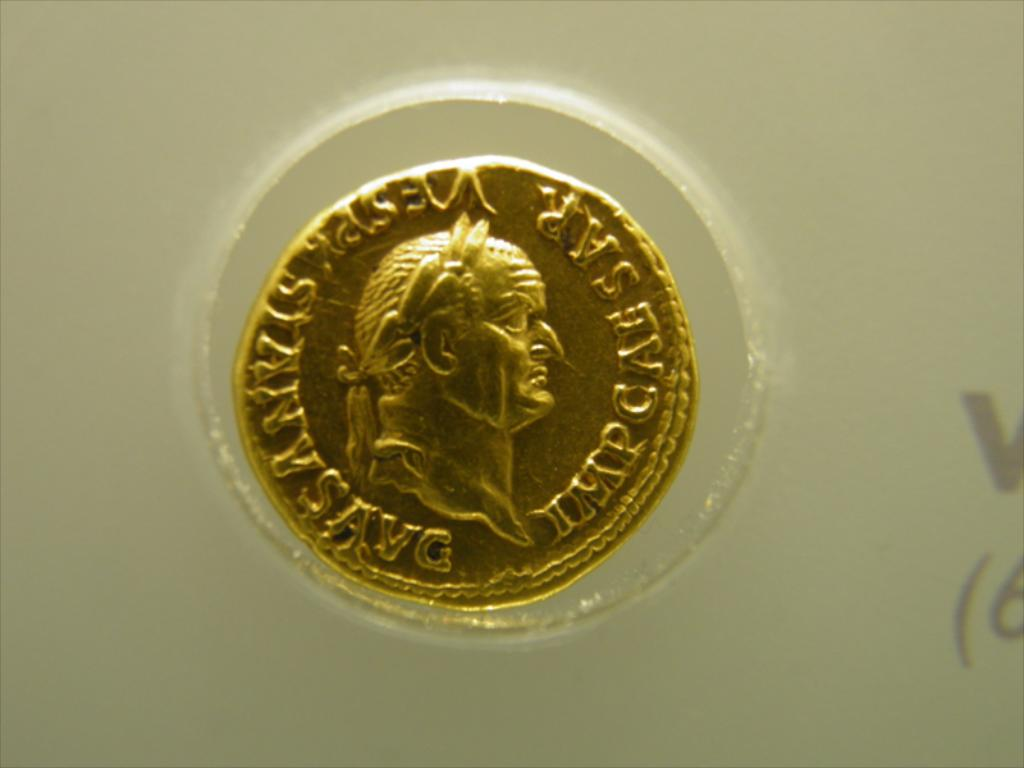What is the historical importance of coins like the one in the image? Coins like the one shown often play significant roles in culture and economy, serving not only as currency but also as a means of disseminating the images of rulers, commemorating significant events, and unifying regions under a common economic system. 